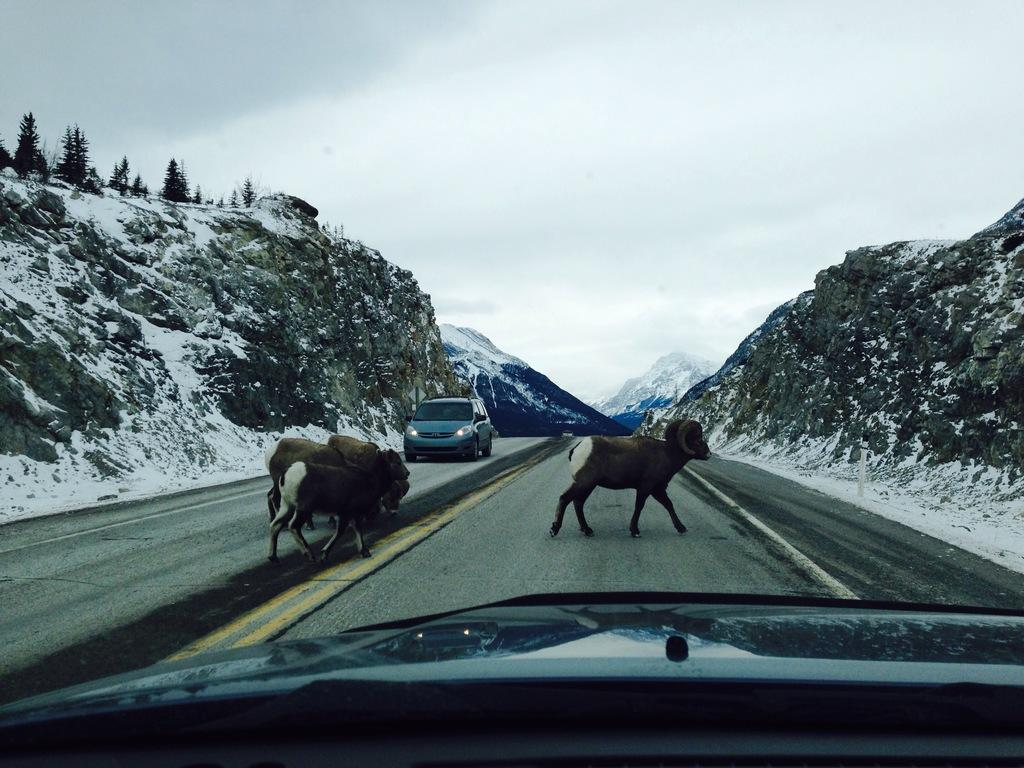What types of living organisms can be seen in the image? There are animals in the image. What is the primary man-made feature in the image? There is a road in the image. What mode of transportation is present in the image? There is a vehicle in the image. Can you describe the black object in the image? There is a black object in the image, but its specific nature cannot be determined from the facts provided. What natural features can be seen in the background of the image? There are mountains, snow, trees, and a cloudy sky in the background of the image. What type of group is protesting on the road in the image? There is no group or protest present in the image; it features animals, a road, a vehicle, and a black object, along with natural features in the background. Can you describe the animals that are flying in the image? There is no mention of animals flying in the image; the animals are not specified, and the image does not depict any flying animals. 